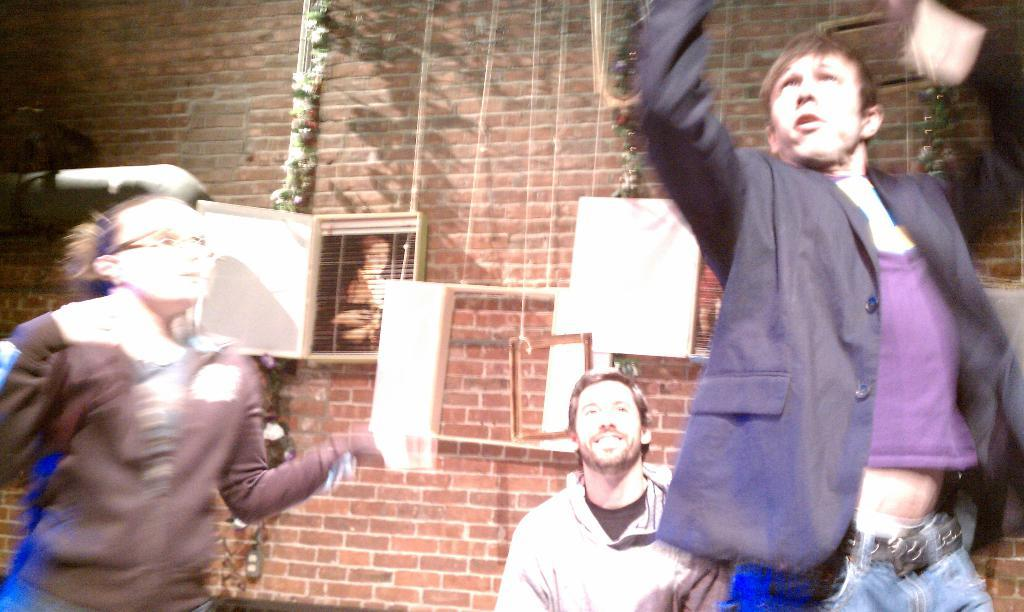Who is on the right side of the image? There is a man on the right side of the image. How many people are in the image in total? There are two men and a girl in the image, making a total of three people. Who is on the left side of the image? There is a girl on the left side of the image. What material is visible in the image? There are bricks visible in the image. What type of teaching is happening in the image? There is no teaching activity depicted in the image. How many chairs are visible in the image? There is no mention of chairs in the provided facts, so we cannot determine the number of chairs in the image. 